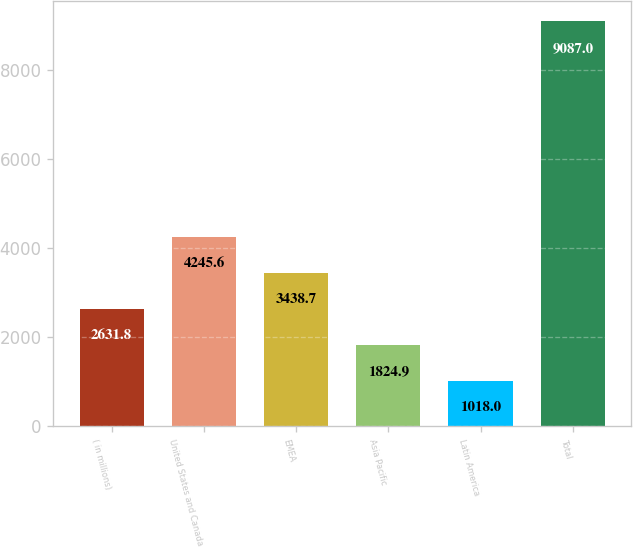Convert chart to OTSL. <chart><loc_0><loc_0><loc_500><loc_500><bar_chart><fcel>( in millions)<fcel>United States and Canada<fcel>EMEA<fcel>Asia Pacific<fcel>Latin America<fcel>Total<nl><fcel>2631.8<fcel>4245.6<fcel>3438.7<fcel>1824.9<fcel>1018<fcel>9087<nl></chart> 